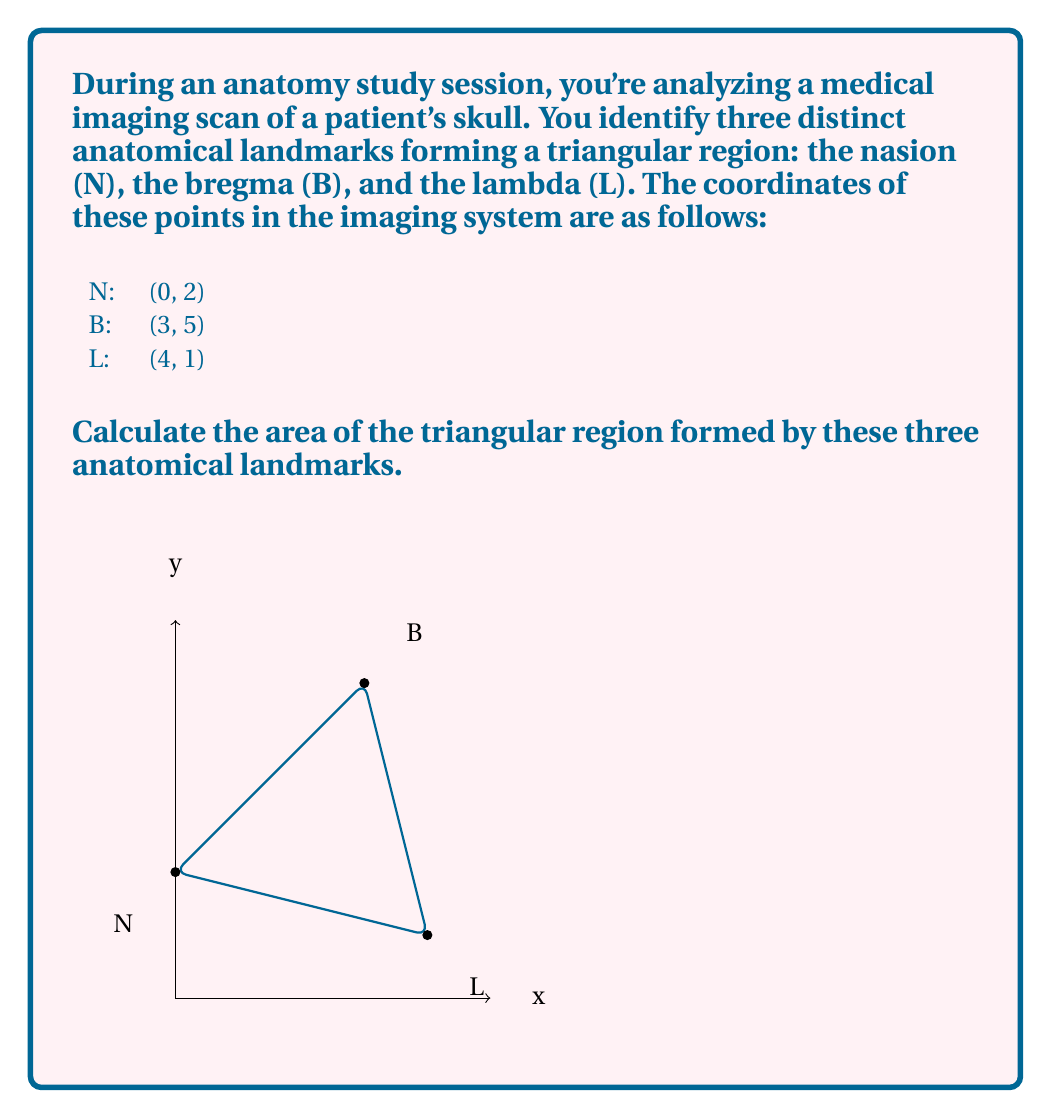What is the answer to this math problem? To calculate the area of a triangle given the coordinates of its vertices, we can use the formula:

$$ \text{Area} = \frac{1}{2}|\text{det}(A)|$$

where A is the matrix:

$$ A = \begin{pmatrix}
x_1 & y_1 & 1 \\
x_2 & y_2 & 1 \\
x_3 & y_3 & 1
\end{pmatrix} $$

Let's follow these steps:

1) First, we create the matrix A using the given coordinates:

$$ A = \begin{pmatrix}
0 & 2 & 1 \\
3 & 5 & 1 \\
4 & 1 & 1
\end{pmatrix} $$

2) Now, we calculate the determinant of this matrix:

$$ \text{det}(A) = 0(5-1) - 2(3-4) + 1(3-8) $$
$$ = 0(4) - 2(-1) + 1(-5) $$
$$ = 0 + 2 - 5 $$
$$ = -3 $$

3) We take the absolute value of this determinant:

$$ |\text{det}(A)| = |-3| = 3 $$

4) Finally, we multiply by $\frac{1}{2}$ to get the area:

$$ \text{Area} = \frac{1}{2} \cdot 3 = 1.5 $$

Therefore, the area of the triangular region formed by these anatomical landmarks is 1.5 square units in the imaging system's scale.
Answer: $1.5$ square units 